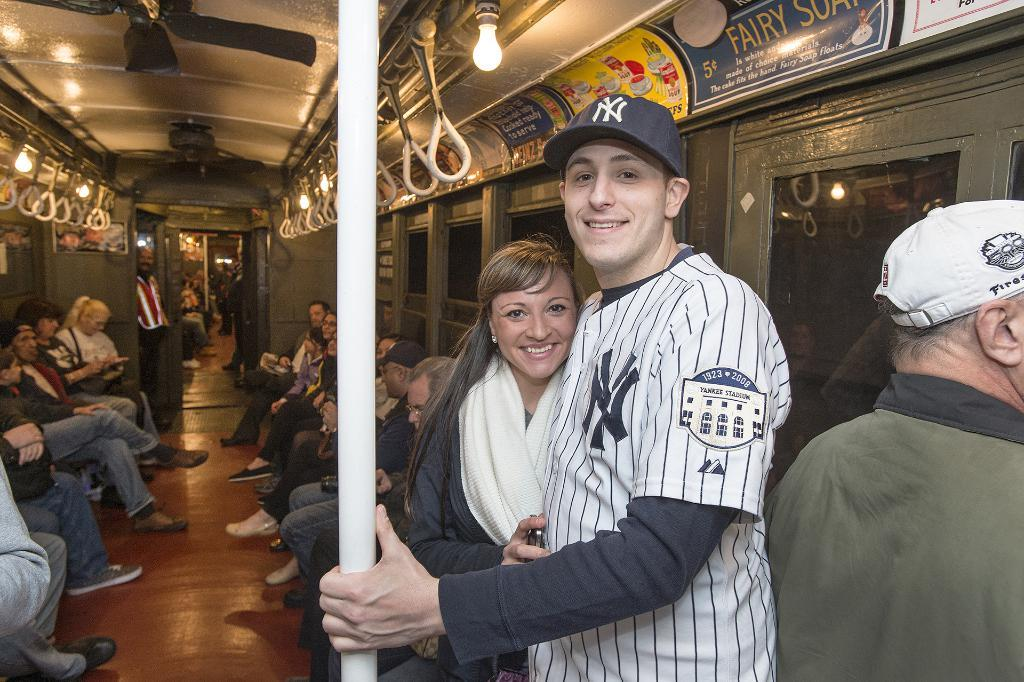<image>
Relay a brief, clear account of the picture shown. A man is a baseball uniform is hugging a woman on a subway and there is an ad above them that says Fairy Soap. 